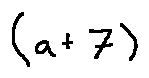<formula> <loc_0><loc_0><loc_500><loc_500>( a + 7 )</formula> 